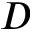Convert formula to latex. <formula><loc_0><loc_0><loc_500><loc_500>D</formula> 